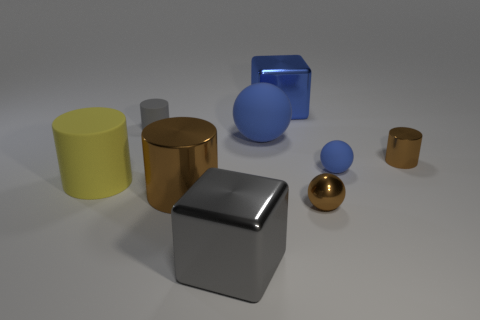Subtract all brown blocks. Subtract all red cylinders. How many blocks are left? 2 Add 1 small gray rubber things. How many objects exist? 10 Subtract all spheres. How many objects are left? 6 Subtract 0 purple cylinders. How many objects are left? 9 Subtract all large gray matte balls. Subtract all small shiny objects. How many objects are left? 7 Add 5 blue spheres. How many blue spheres are left? 7 Add 2 gray metallic blocks. How many gray metallic blocks exist? 3 